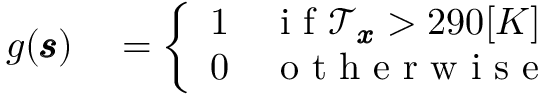<formula> <loc_0><loc_0><loc_500><loc_500>\begin{array} { r l } { g ( \pm b { \ m a t h s c r { s } } ) } & = \left \{ \begin{array} { l l } { 1 } & { i f \ m a t h s c r { T } _ { \pm b { x } } > 2 9 0 [ K ] } \\ { 0 } & { o t h e r w i s e } \end{array} } \end{array}</formula> 